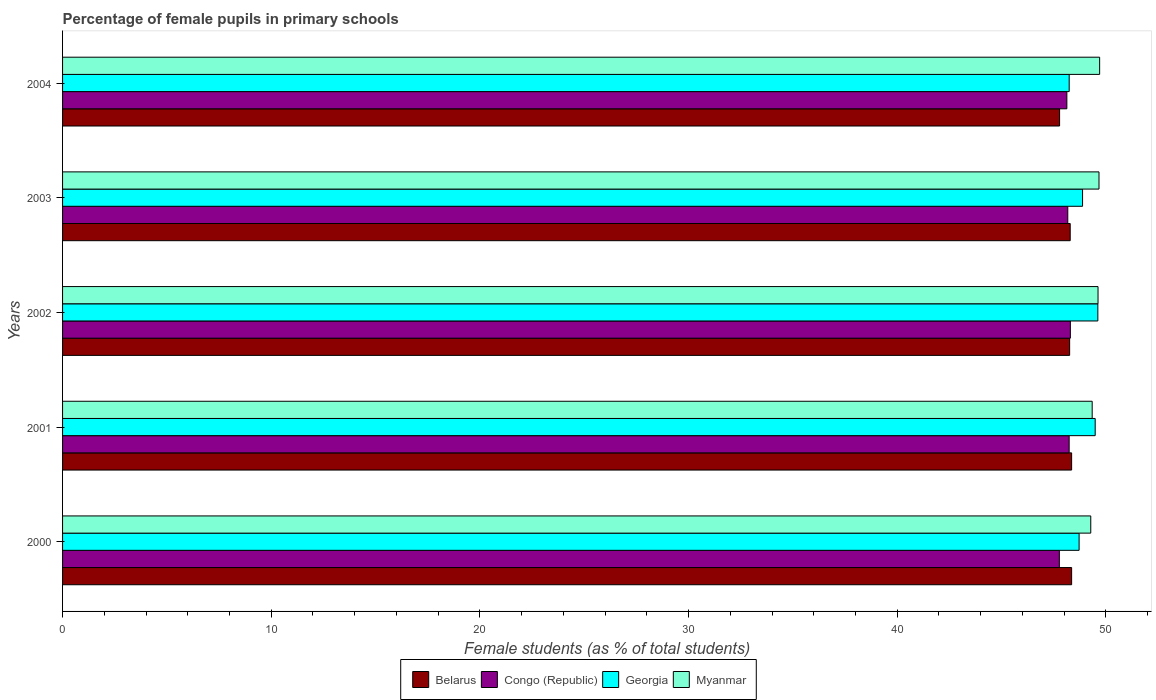Are the number of bars per tick equal to the number of legend labels?
Provide a succinct answer. Yes. How many bars are there on the 3rd tick from the bottom?
Keep it short and to the point. 4. What is the label of the 3rd group of bars from the top?
Make the answer very short. 2002. In how many cases, is the number of bars for a given year not equal to the number of legend labels?
Give a very brief answer. 0. What is the percentage of female pupils in primary schools in Myanmar in 2004?
Your answer should be very brief. 49.7. Across all years, what is the maximum percentage of female pupils in primary schools in Georgia?
Your answer should be compact. 49.62. Across all years, what is the minimum percentage of female pupils in primary schools in Myanmar?
Offer a terse response. 49.28. In which year was the percentage of female pupils in primary schools in Congo (Republic) minimum?
Provide a succinct answer. 2000. What is the total percentage of female pupils in primary schools in Myanmar in the graph?
Give a very brief answer. 247.62. What is the difference between the percentage of female pupils in primary schools in Myanmar in 2002 and that in 2004?
Offer a terse response. -0.08. What is the difference between the percentage of female pupils in primary schools in Congo (Republic) in 2004 and the percentage of female pupils in primary schools in Georgia in 2001?
Your response must be concise. -1.36. What is the average percentage of female pupils in primary schools in Myanmar per year?
Give a very brief answer. 49.52. In the year 2003, what is the difference between the percentage of female pupils in primary schools in Belarus and percentage of female pupils in primary schools in Myanmar?
Provide a short and direct response. -1.38. In how many years, is the percentage of female pupils in primary schools in Myanmar greater than 50 %?
Provide a succinct answer. 0. What is the ratio of the percentage of female pupils in primary schools in Georgia in 2000 to that in 2003?
Provide a short and direct response. 1. Is the percentage of female pupils in primary schools in Congo (Republic) in 2002 less than that in 2003?
Keep it short and to the point. No. What is the difference between the highest and the second highest percentage of female pupils in primary schools in Congo (Republic)?
Provide a succinct answer. 0.06. What is the difference between the highest and the lowest percentage of female pupils in primary schools in Congo (Republic)?
Make the answer very short. 0.53. Is the sum of the percentage of female pupils in primary schools in Georgia in 2002 and 2004 greater than the maximum percentage of female pupils in primary schools in Congo (Republic) across all years?
Give a very brief answer. Yes. Is it the case that in every year, the sum of the percentage of female pupils in primary schools in Belarus and percentage of female pupils in primary schools in Congo (Republic) is greater than the sum of percentage of female pupils in primary schools in Myanmar and percentage of female pupils in primary schools in Georgia?
Make the answer very short. No. What does the 4th bar from the top in 2002 represents?
Provide a short and direct response. Belarus. What does the 1st bar from the bottom in 2000 represents?
Make the answer very short. Belarus. Is it the case that in every year, the sum of the percentage of female pupils in primary schools in Congo (Republic) and percentage of female pupils in primary schools in Belarus is greater than the percentage of female pupils in primary schools in Georgia?
Provide a succinct answer. Yes. How many bars are there?
Keep it short and to the point. 20. Are all the bars in the graph horizontal?
Give a very brief answer. Yes. How many years are there in the graph?
Your response must be concise. 5. What is the difference between two consecutive major ticks on the X-axis?
Offer a terse response. 10. Does the graph contain any zero values?
Offer a very short reply. No. Where does the legend appear in the graph?
Your answer should be very brief. Bottom center. How many legend labels are there?
Make the answer very short. 4. How are the legend labels stacked?
Keep it short and to the point. Horizontal. What is the title of the graph?
Your answer should be compact. Percentage of female pupils in primary schools. Does "Liberia" appear as one of the legend labels in the graph?
Your answer should be compact. No. What is the label or title of the X-axis?
Make the answer very short. Female students (as % of total students). What is the Female students (as % of total students) in Belarus in 2000?
Make the answer very short. 48.36. What is the Female students (as % of total students) in Congo (Republic) in 2000?
Provide a short and direct response. 47.77. What is the Female students (as % of total students) in Georgia in 2000?
Provide a succinct answer. 48.72. What is the Female students (as % of total students) in Myanmar in 2000?
Offer a very short reply. 49.28. What is the Female students (as % of total students) of Belarus in 2001?
Offer a very short reply. 48.36. What is the Female students (as % of total students) of Congo (Republic) in 2001?
Provide a short and direct response. 48.24. What is the Female students (as % of total students) of Georgia in 2001?
Your answer should be very brief. 49.49. What is the Female students (as % of total students) in Myanmar in 2001?
Your answer should be very brief. 49.35. What is the Female students (as % of total students) of Belarus in 2002?
Provide a short and direct response. 48.26. What is the Female students (as % of total students) in Congo (Republic) in 2002?
Your answer should be compact. 48.3. What is the Female students (as % of total students) in Georgia in 2002?
Offer a terse response. 49.62. What is the Female students (as % of total students) of Myanmar in 2002?
Ensure brevity in your answer.  49.63. What is the Female students (as % of total students) of Belarus in 2003?
Your response must be concise. 48.29. What is the Female students (as % of total students) of Congo (Republic) in 2003?
Your response must be concise. 48.18. What is the Female students (as % of total students) in Georgia in 2003?
Make the answer very short. 48.88. What is the Female students (as % of total students) in Myanmar in 2003?
Keep it short and to the point. 49.67. What is the Female students (as % of total students) in Belarus in 2004?
Ensure brevity in your answer.  47.78. What is the Female students (as % of total students) of Congo (Republic) in 2004?
Keep it short and to the point. 48.13. What is the Female students (as % of total students) in Georgia in 2004?
Ensure brevity in your answer.  48.24. What is the Female students (as % of total students) of Myanmar in 2004?
Ensure brevity in your answer.  49.7. Across all years, what is the maximum Female students (as % of total students) of Belarus?
Offer a terse response. 48.36. Across all years, what is the maximum Female students (as % of total students) of Congo (Republic)?
Keep it short and to the point. 48.3. Across all years, what is the maximum Female students (as % of total students) in Georgia?
Ensure brevity in your answer.  49.62. Across all years, what is the maximum Female students (as % of total students) in Myanmar?
Your answer should be very brief. 49.7. Across all years, what is the minimum Female students (as % of total students) of Belarus?
Provide a succinct answer. 47.78. Across all years, what is the minimum Female students (as % of total students) of Congo (Republic)?
Offer a terse response. 47.77. Across all years, what is the minimum Female students (as % of total students) of Georgia?
Offer a very short reply. 48.24. Across all years, what is the minimum Female students (as % of total students) in Myanmar?
Keep it short and to the point. 49.28. What is the total Female students (as % of total students) of Belarus in the graph?
Offer a very short reply. 241.06. What is the total Female students (as % of total students) in Congo (Republic) in the graph?
Offer a very short reply. 240.62. What is the total Female students (as % of total students) in Georgia in the graph?
Provide a short and direct response. 244.95. What is the total Female students (as % of total students) in Myanmar in the graph?
Your answer should be compact. 247.62. What is the difference between the Female students (as % of total students) in Belarus in 2000 and that in 2001?
Ensure brevity in your answer.  0. What is the difference between the Female students (as % of total students) in Congo (Republic) in 2000 and that in 2001?
Provide a succinct answer. -0.47. What is the difference between the Female students (as % of total students) of Georgia in 2000 and that in 2001?
Keep it short and to the point. -0.77. What is the difference between the Female students (as % of total students) of Myanmar in 2000 and that in 2001?
Offer a terse response. -0.07. What is the difference between the Female students (as % of total students) of Belarus in 2000 and that in 2002?
Offer a very short reply. 0.1. What is the difference between the Female students (as % of total students) in Congo (Republic) in 2000 and that in 2002?
Ensure brevity in your answer.  -0.53. What is the difference between the Female students (as % of total students) in Georgia in 2000 and that in 2002?
Provide a short and direct response. -0.9. What is the difference between the Female students (as % of total students) of Myanmar in 2000 and that in 2002?
Keep it short and to the point. -0.35. What is the difference between the Female students (as % of total students) in Belarus in 2000 and that in 2003?
Your response must be concise. 0.07. What is the difference between the Female students (as % of total students) of Congo (Republic) in 2000 and that in 2003?
Provide a short and direct response. -0.4. What is the difference between the Female students (as % of total students) of Georgia in 2000 and that in 2003?
Ensure brevity in your answer.  -0.17. What is the difference between the Female students (as % of total students) in Myanmar in 2000 and that in 2003?
Provide a short and direct response. -0.39. What is the difference between the Female students (as % of total students) in Belarus in 2000 and that in 2004?
Provide a short and direct response. 0.58. What is the difference between the Female students (as % of total students) of Congo (Republic) in 2000 and that in 2004?
Offer a very short reply. -0.36. What is the difference between the Female students (as % of total students) of Georgia in 2000 and that in 2004?
Provide a short and direct response. 0.47. What is the difference between the Female students (as % of total students) of Myanmar in 2000 and that in 2004?
Make the answer very short. -0.43. What is the difference between the Female students (as % of total students) of Belarus in 2001 and that in 2002?
Make the answer very short. 0.1. What is the difference between the Female students (as % of total students) in Congo (Republic) in 2001 and that in 2002?
Offer a very short reply. -0.06. What is the difference between the Female students (as % of total students) of Georgia in 2001 and that in 2002?
Keep it short and to the point. -0.13. What is the difference between the Female students (as % of total students) of Myanmar in 2001 and that in 2002?
Ensure brevity in your answer.  -0.28. What is the difference between the Female students (as % of total students) in Belarus in 2001 and that in 2003?
Provide a short and direct response. 0.07. What is the difference between the Female students (as % of total students) of Congo (Republic) in 2001 and that in 2003?
Offer a very short reply. 0.07. What is the difference between the Female students (as % of total students) of Georgia in 2001 and that in 2003?
Your answer should be very brief. 0.61. What is the difference between the Female students (as % of total students) in Myanmar in 2001 and that in 2003?
Offer a very short reply. -0.33. What is the difference between the Female students (as % of total students) of Belarus in 2001 and that in 2004?
Keep it short and to the point. 0.58. What is the difference between the Female students (as % of total students) of Congo (Republic) in 2001 and that in 2004?
Make the answer very short. 0.11. What is the difference between the Female students (as % of total students) in Georgia in 2001 and that in 2004?
Offer a very short reply. 1.25. What is the difference between the Female students (as % of total students) of Myanmar in 2001 and that in 2004?
Keep it short and to the point. -0.36. What is the difference between the Female students (as % of total students) in Belarus in 2002 and that in 2003?
Make the answer very short. -0.03. What is the difference between the Female students (as % of total students) in Congo (Republic) in 2002 and that in 2003?
Provide a succinct answer. 0.12. What is the difference between the Female students (as % of total students) in Georgia in 2002 and that in 2003?
Make the answer very short. 0.73. What is the difference between the Female students (as % of total students) in Myanmar in 2002 and that in 2003?
Provide a short and direct response. -0.05. What is the difference between the Female students (as % of total students) of Belarus in 2002 and that in 2004?
Provide a succinct answer. 0.48. What is the difference between the Female students (as % of total students) of Congo (Republic) in 2002 and that in 2004?
Offer a terse response. 0.17. What is the difference between the Female students (as % of total students) of Georgia in 2002 and that in 2004?
Your response must be concise. 1.37. What is the difference between the Female students (as % of total students) of Myanmar in 2002 and that in 2004?
Offer a terse response. -0.08. What is the difference between the Female students (as % of total students) of Belarus in 2003 and that in 2004?
Offer a very short reply. 0.51. What is the difference between the Female students (as % of total students) in Congo (Republic) in 2003 and that in 2004?
Give a very brief answer. 0.04. What is the difference between the Female students (as % of total students) of Georgia in 2003 and that in 2004?
Provide a short and direct response. 0.64. What is the difference between the Female students (as % of total students) in Myanmar in 2003 and that in 2004?
Your answer should be compact. -0.03. What is the difference between the Female students (as % of total students) in Belarus in 2000 and the Female students (as % of total students) in Congo (Republic) in 2001?
Keep it short and to the point. 0.12. What is the difference between the Female students (as % of total students) of Belarus in 2000 and the Female students (as % of total students) of Georgia in 2001?
Your response must be concise. -1.13. What is the difference between the Female students (as % of total students) of Belarus in 2000 and the Female students (as % of total students) of Myanmar in 2001?
Provide a succinct answer. -0.98. What is the difference between the Female students (as % of total students) of Congo (Republic) in 2000 and the Female students (as % of total students) of Georgia in 2001?
Your answer should be very brief. -1.72. What is the difference between the Female students (as % of total students) of Congo (Republic) in 2000 and the Female students (as % of total students) of Myanmar in 2001?
Offer a terse response. -1.57. What is the difference between the Female students (as % of total students) of Georgia in 2000 and the Female students (as % of total students) of Myanmar in 2001?
Your answer should be very brief. -0.63. What is the difference between the Female students (as % of total students) in Belarus in 2000 and the Female students (as % of total students) in Congo (Republic) in 2002?
Your answer should be very brief. 0.06. What is the difference between the Female students (as % of total students) in Belarus in 2000 and the Female students (as % of total students) in Georgia in 2002?
Your answer should be very brief. -1.26. What is the difference between the Female students (as % of total students) in Belarus in 2000 and the Female students (as % of total students) in Myanmar in 2002?
Give a very brief answer. -1.27. What is the difference between the Female students (as % of total students) of Congo (Republic) in 2000 and the Female students (as % of total students) of Georgia in 2002?
Provide a succinct answer. -1.85. What is the difference between the Female students (as % of total students) of Congo (Republic) in 2000 and the Female students (as % of total students) of Myanmar in 2002?
Your answer should be very brief. -1.85. What is the difference between the Female students (as % of total students) in Georgia in 2000 and the Female students (as % of total students) in Myanmar in 2002?
Your answer should be compact. -0.91. What is the difference between the Female students (as % of total students) of Belarus in 2000 and the Female students (as % of total students) of Congo (Republic) in 2003?
Your answer should be compact. 0.18. What is the difference between the Female students (as % of total students) in Belarus in 2000 and the Female students (as % of total students) in Georgia in 2003?
Ensure brevity in your answer.  -0.52. What is the difference between the Female students (as % of total students) of Belarus in 2000 and the Female students (as % of total students) of Myanmar in 2003?
Offer a very short reply. -1.31. What is the difference between the Female students (as % of total students) in Congo (Republic) in 2000 and the Female students (as % of total students) in Georgia in 2003?
Offer a very short reply. -1.11. What is the difference between the Female students (as % of total students) in Georgia in 2000 and the Female students (as % of total students) in Myanmar in 2003?
Your answer should be compact. -0.95. What is the difference between the Female students (as % of total students) of Belarus in 2000 and the Female students (as % of total students) of Congo (Republic) in 2004?
Provide a short and direct response. 0.23. What is the difference between the Female students (as % of total students) of Belarus in 2000 and the Female students (as % of total students) of Georgia in 2004?
Provide a short and direct response. 0.12. What is the difference between the Female students (as % of total students) of Belarus in 2000 and the Female students (as % of total students) of Myanmar in 2004?
Your answer should be very brief. -1.34. What is the difference between the Female students (as % of total students) of Congo (Republic) in 2000 and the Female students (as % of total students) of Georgia in 2004?
Provide a succinct answer. -0.47. What is the difference between the Female students (as % of total students) of Congo (Republic) in 2000 and the Female students (as % of total students) of Myanmar in 2004?
Ensure brevity in your answer.  -1.93. What is the difference between the Female students (as % of total students) of Georgia in 2000 and the Female students (as % of total students) of Myanmar in 2004?
Provide a short and direct response. -0.98. What is the difference between the Female students (as % of total students) in Belarus in 2001 and the Female students (as % of total students) in Congo (Republic) in 2002?
Provide a short and direct response. 0.06. What is the difference between the Female students (as % of total students) of Belarus in 2001 and the Female students (as % of total students) of Georgia in 2002?
Give a very brief answer. -1.26. What is the difference between the Female students (as % of total students) of Belarus in 2001 and the Female students (as % of total students) of Myanmar in 2002?
Give a very brief answer. -1.27. What is the difference between the Female students (as % of total students) of Congo (Republic) in 2001 and the Female students (as % of total students) of Georgia in 2002?
Provide a succinct answer. -1.37. What is the difference between the Female students (as % of total students) of Congo (Republic) in 2001 and the Female students (as % of total students) of Myanmar in 2002?
Offer a terse response. -1.38. What is the difference between the Female students (as % of total students) of Georgia in 2001 and the Female students (as % of total students) of Myanmar in 2002?
Provide a short and direct response. -0.14. What is the difference between the Female students (as % of total students) of Belarus in 2001 and the Female students (as % of total students) of Congo (Republic) in 2003?
Offer a very short reply. 0.18. What is the difference between the Female students (as % of total students) in Belarus in 2001 and the Female students (as % of total students) in Georgia in 2003?
Your response must be concise. -0.52. What is the difference between the Female students (as % of total students) in Belarus in 2001 and the Female students (as % of total students) in Myanmar in 2003?
Your answer should be very brief. -1.31. What is the difference between the Female students (as % of total students) of Congo (Republic) in 2001 and the Female students (as % of total students) of Georgia in 2003?
Provide a short and direct response. -0.64. What is the difference between the Female students (as % of total students) of Congo (Republic) in 2001 and the Female students (as % of total students) of Myanmar in 2003?
Ensure brevity in your answer.  -1.43. What is the difference between the Female students (as % of total students) of Georgia in 2001 and the Female students (as % of total students) of Myanmar in 2003?
Your answer should be compact. -0.18. What is the difference between the Female students (as % of total students) of Belarus in 2001 and the Female students (as % of total students) of Congo (Republic) in 2004?
Offer a very short reply. 0.23. What is the difference between the Female students (as % of total students) in Belarus in 2001 and the Female students (as % of total students) in Georgia in 2004?
Your response must be concise. 0.12. What is the difference between the Female students (as % of total students) of Belarus in 2001 and the Female students (as % of total students) of Myanmar in 2004?
Provide a short and direct response. -1.34. What is the difference between the Female students (as % of total students) of Congo (Republic) in 2001 and the Female students (as % of total students) of Georgia in 2004?
Make the answer very short. -0. What is the difference between the Female students (as % of total students) of Congo (Republic) in 2001 and the Female students (as % of total students) of Myanmar in 2004?
Keep it short and to the point. -1.46. What is the difference between the Female students (as % of total students) of Georgia in 2001 and the Female students (as % of total students) of Myanmar in 2004?
Provide a short and direct response. -0.21. What is the difference between the Female students (as % of total students) of Belarus in 2002 and the Female students (as % of total students) of Congo (Republic) in 2003?
Your response must be concise. 0.09. What is the difference between the Female students (as % of total students) in Belarus in 2002 and the Female students (as % of total students) in Georgia in 2003?
Your answer should be compact. -0.62. What is the difference between the Female students (as % of total students) of Belarus in 2002 and the Female students (as % of total students) of Myanmar in 2003?
Give a very brief answer. -1.41. What is the difference between the Female students (as % of total students) of Congo (Republic) in 2002 and the Female students (as % of total students) of Georgia in 2003?
Provide a succinct answer. -0.59. What is the difference between the Female students (as % of total students) of Congo (Republic) in 2002 and the Female students (as % of total students) of Myanmar in 2003?
Ensure brevity in your answer.  -1.37. What is the difference between the Female students (as % of total students) of Georgia in 2002 and the Female students (as % of total students) of Myanmar in 2003?
Your answer should be compact. -0.05. What is the difference between the Female students (as % of total students) of Belarus in 2002 and the Female students (as % of total students) of Congo (Republic) in 2004?
Your answer should be very brief. 0.13. What is the difference between the Female students (as % of total students) of Belarus in 2002 and the Female students (as % of total students) of Georgia in 2004?
Keep it short and to the point. 0.02. What is the difference between the Female students (as % of total students) in Belarus in 2002 and the Female students (as % of total students) in Myanmar in 2004?
Provide a succinct answer. -1.44. What is the difference between the Female students (as % of total students) in Congo (Republic) in 2002 and the Female students (as % of total students) in Georgia in 2004?
Ensure brevity in your answer.  0.06. What is the difference between the Female students (as % of total students) of Congo (Republic) in 2002 and the Female students (as % of total students) of Myanmar in 2004?
Your response must be concise. -1.4. What is the difference between the Female students (as % of total students) in Georgia in 2002 and the Female students (as % of total students) in Myanmar in 2004?
Ensure brevity in your answer.  -0.09. What is the difference between the Female students (as % of total students) in Belarus in 2003 and the Female students (as % of total students) in Congo (Republic) in 2004?
Provide a succinct answer. 0.16. What is the difference between the Female students (as % of total students) of Belarus in 2003 and the Female students (as % of total students) of Georgia in 2004?
Offer a terse response. 0.05. What is the difference between the Female students (as % of total students) in Belarus in 2003 and the Female students (as % of total students) in Myanmar in 2004?
Provide a succinct answer. -1.41. What is the difference between the Female students (as % of total students) of Congo (Republic) in 2003 and the Female students (as % of total students) of Georgia in 2004?
Give a very brief answer. -0.07. What is the difference between the Female students (as % of total students) of Congo (Republic) in 2003 and the Female students (as % of total students) of Myanmar in 2004?
Your answer should be compact. -1.53. What is the difference between the Female students (as % of total students) in Georgia in 2003 and the Female students (as % of total students) in Myanmar in 2004?
Offer a very short reply. -0.82. What is the average Female students (as % of total students) in Belarus per year?
Make the answer very short. 48.21. What is the average Female students (as % of total students) in Congo (Republic) per year?
Your answer should be very brief. 48.12. What is the average Female students (as % of total students) in Georgia per year?
Make the answer very short. 48.99. What is the average Female students (as % of total students) in Myanmar per year?
Give a very brief answer. 49.52. In the year 2000, what is the difference between the Female students (as % of total students) of Belarus and Female students (as % of total students) of Congo (Republic)?
Provide a short and direct response. 0.59. In the year 2000, what is the difference between the Female students (as % of total students) of Belarus and Female students (as % of total students) of Georgia?
Give a very brief answer. -0.36. In the year 2000, what is the difference between the Female students (as % of total students) of Belarus and Female students (as % of total students) of Myanmar?
Your response must be concise. -0.92. In the year 2000, what is the difference between the Female students (as % of total students) in Congo (Republic) and Female students (as % of total students) in Georgia?
Provide a short and direct response. -0.95. In the year 2000, what is the difference between the Female students (as % of total students) of Congo (Republic) and Female students (as % of total students) of Myanmar?
Provide a short and direct response. -1.51. In the year 2000, what is the difference between the Female students (as % of total students) of Georgia and Female students (as % of total students) of Myanmar?
Give a very brief answer. -0.56. In the year 2001, what is the difference between the Female students (as % of total students) in Belarus and Female students (as % of total students) in Congo (Republic)?
Ensure brevity in your answer.  0.12. In the year 2001, what is the difference between the Female students (as % of total students) of Belarus and Female students (as % of total students) of Georgia?
Offer a very short reply. -1.13. In the year 2001, what is the difference between the Female students (as % of total students) in Belarus and Female students (as % of total students) in Myanmar?
Ensure brevity in your answer.  -0.99. In the year 2001, what is the difference between the Female students (as % of total students) in Congo (Republic) and Female students (as % of total students) in Georgia?
Your answer should be compact. -1.25. In the year 2001, what is the difference between the Female students (as % of total students) in Congo (Republic) and Female students (as % of total students) in Myanmar?
Your response must be concise. -1.1. In the year 2001, what is the difference between the Female students (as % of total students) in Georgia and Female students (as % of total students) in Myanmar?
Offer a very short reply. 0.14. In the year 2002, what is the difference between the Female students (as % of total students) of Belarus and Female students (as % of total students) of Congo (Republic)?
Your response must be concise. -0.03. In the year 2002, what is the difference between the Female students (as % of total students) of Belarus and Female students (as % of total students) of Georgia?
Offer a terse response. -1.35. In the year 2002, what is the difference between the Female students (as % of total students) of Belarus and Female students (as % of total students) of Myanmar?
Offer a very short reply. -1.36. In the year 2002, what is the difference between the Female students (as % of total students) in Congo (Republic) and Female students (as % of total students) in Georgia?
Keep it short and to the point. -1.32. In the year 2002, what is the difference between the Female students (as % of total students) in Congo (Republic) and Female students (as % of total students) in Myanmar?
Ensure brevity in your answer.  -1.33. In the year 2002, what is the difference between the Female students (as % of total students) of Georgia and Female students (as % of total students) of Myanmar?
Your answer should be compact. -0.01. In the year 2003, what is the difference between the Female students (as % of total students) in Belarus and Female students (as % of total students) in Congo (Republic)?
Ensure brevity in your answer.  0.12. In the year 2003, what is the difference between the Female students (as % of total students) of Belarus and Female students (as % of total students) of Georgia?
Keep it short and to the point. -0.59. In the year 2003, what is the difference between the Female students (as % of total students) in Belarus and Female students (as % of total students) in Myanmar?
Your answer should be compact. -1.38. In the year 2003, what is the difference between the Female students (as % of total students) in Congo (Republic) and Female students (as % of total students) in Georgia?
Your response must be concise. -0.71. In the year 2003, what is the difference between the Female students (as % of total students) of Congo (Republic) and Female students (as % of total students) of Myanmar?
Offer a terse response. -1.5. In the year 2003, what is the difference between the Female students (as % of total students) in Georgia and Female students (as % of total students) in Myanmar?
Your answer should be compact. -0.79. In the year 2004, what is the difference between the Female students (as % of total students) of Belarus and Female students (as % of total students) of Congo (Republic)?
Give a very brief answer. -0.35. In the year 2004, what is the difference between the Female students (as % of total students) in Belarus and Female students (as % of total students) in Georgia?
Offer a very short reply. -0.46. In the year 2004, what is the difference between the Female students (as % of total students) in Belarus and Female students (as % of total students) in Myanmar?
Offer a terse response. -1.92. In the year 2004, what is the difference between the Female students (as % of total students) of Congo (Republic) and Female students (as % of total students) of Georgia?
Your answer should be very brief. -0.11. In the year 2004, what is the difference between the Female students (as % of total students) of Congo (Republic) and Female students (as % of total students) of Myanmar?
Provide a succinct answer. -1.57. In the year 2004, what is the difference between the Female students (as % of total students) in Georgia and Female students (as % of total students) in Myanmar?
Provide a short and direct response. -1.46. What is the ratio of the Female students (as % of total students) in Belarus in 2000 to that in 2001?
Your answer should be compact. 1. What is the ratio of the Female students (as % of total students) in Congo (Republic) in 2000 to that in 2001?
Provide a succinct answer. 0.99. What is the ratio of the Female students (as % of total students) in Georgia in 2000 to that in 2001?
Provide a succinct answer. 0.98. What is the ratio of the Female students (as % of total students) of Georgia in 2000 to that in 2002?
Your answer should be very brief. 0.98. What is the ratio of the Female students (as % of total students) of Belarus in 2000 to that in 2004?
Your answer should be compact. 1.01. What is the ratio of the Female students (as % of total students) of Congo (Republic) in 2000 to that in 2004?
Provide a succinct answer. 0.99. What is the ratio of the Female students (as % of total students) of Georgia in 2000 to that in 2004?
Your response must be concise. 1.01. What is the ratio of the Female students (as % of total students) of Myanmar in 2000 to that in 2004?
Provide a short and direct response. 0.99. What is the ratio of the Female students (as % of total students) of Congo (Republic) in 2001 to that in 2002?
Make the answer very short. 1. What is the ratio of the Female students (as % of total students) in Georgia in 2001 to that in 2002?
Your answer should be very brief. 1. What is the ratio of the Female students (as % of total students) in Myanmar in 2001 to that in 2002?
Ensure brevity in your answer.  0.99. What is the ratio of the Female students (as % of total students) of Belarus in 2001 to that in 2003?
Keep it short and to the point. 1. What is the ratio of the Female students (as % of total students) in Georgia in 2001 to that in 2003?
Ensure brevity in your answer.  1.01. What is the ratio of the Female students (as % of total students) in Myanmar in 2001 to that in 2003?
Ensure brevity in your answer.  0.99. What is the ratio of the Female students (as % of total students) of Belarus in 2001 to that in 2004?
Provide a short and direct response. 1.01. What is the ratio of the Female students (as % of total students) of Georgia in 2001 to that in 2004?
Provide a short and direct response. 1.03. What is the ratio of the Female students (as % of total students) of Congo (Republic) in 2002 to that in 2003?
Offer a terse response. 1. What is the ratio of the Female students (as % of total students) of Georgia in 2002 to that in 2003?
Offer a very short reply. 1.01. What is the ratio of the Female students (as % of total students) in Belarus in 2002 to that in 2004?
Your answer should be compact. 1.01. What is the ratio of the Female students (as % of total students) in Georgia in 2002 to that in 2004?
Your response must be concise. 1.03. What is the ratio of the Female students (as % of total students) in Myanmar in 2002 to that in 2004?
Make the answer very short. 1. What is the ratio of the Female students (as % of total students) in Belarus in 2003 to that in 2004?
Make the answer very short. 1.01. What is the ratio of the Female students (as % of total students) of Congo (Republic) in 2003 to that in 2004?
Your response must be concise. 1. What is the ratio of the Female students (as % of total students) in Georgia in 2003 to that in 2004?
Offer a very short reply. 1.01. What is the difference between the highest and the second highest Female students (as % of total students) in Congo (Republic)?
Your answer should be very brief. 0.06. What is the difference between the highest and the second highest Female students (as % of total students) of Georgia?
Ensure brevity in your answer.  0.13. What is the difference between the highest and the second highest Female students (as % of total students) in Myanmar?
Provide a short and direct response. 0.03. What is the difference between the highest and the lowest Female students (as % of total students) in Belarus?
Keep it short and to the point. 0.58. What is the difference between the highest and the lowest Female students (as % of total students) of Congo (Republic)?
Provide a succinct answer. 0.53. What is the difference between the highest and the lowest Female students (as % of total students) in Georgia?
Ensure brevity in your answer.  1.37. What is the difference between the highest and the lowest Female students (as % of total students) in Myanmar?
Offer a very short reply. 0.43. 